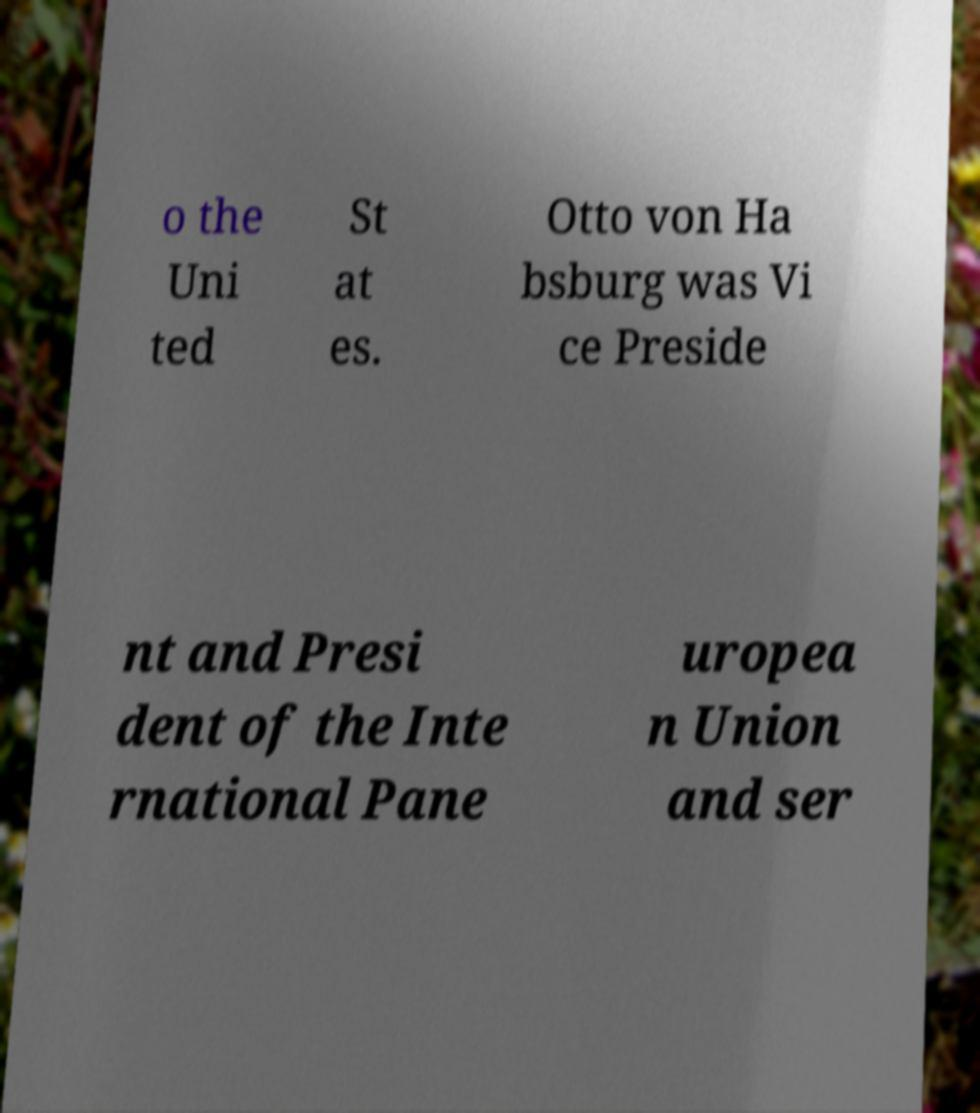Can you read and provide the text displayed in the image?This photo seems to have some interesting text. Can you extract and type it out for me? o the Uni ted St at es. Otto von Ha bsburg was Vi ce Preside nt and Presi dent of the Inte rnational Pane uropea n Union and ser 